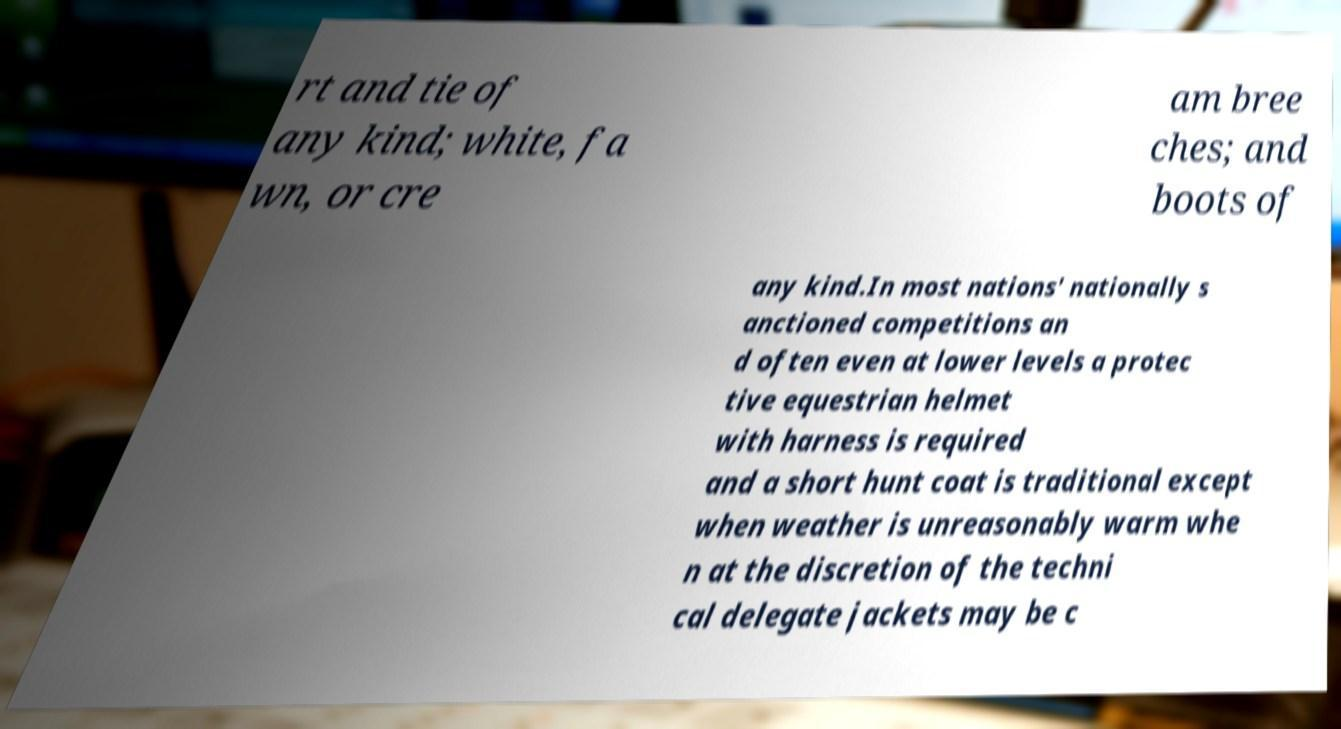Could you assist in decoding the text presented in this image and type it out clearly? rt and tie of any kind; white, fa wn, or cre am bree ches; and boots of any kind.In most nations' nationally s anctioned competitions an d often even at lower levels a protec tive equestrian helmet with harness is required and a short hunt coat is traditional except when weather is unreasonably warm whe n at the discretion of the techni cal delegate jackets may be c 